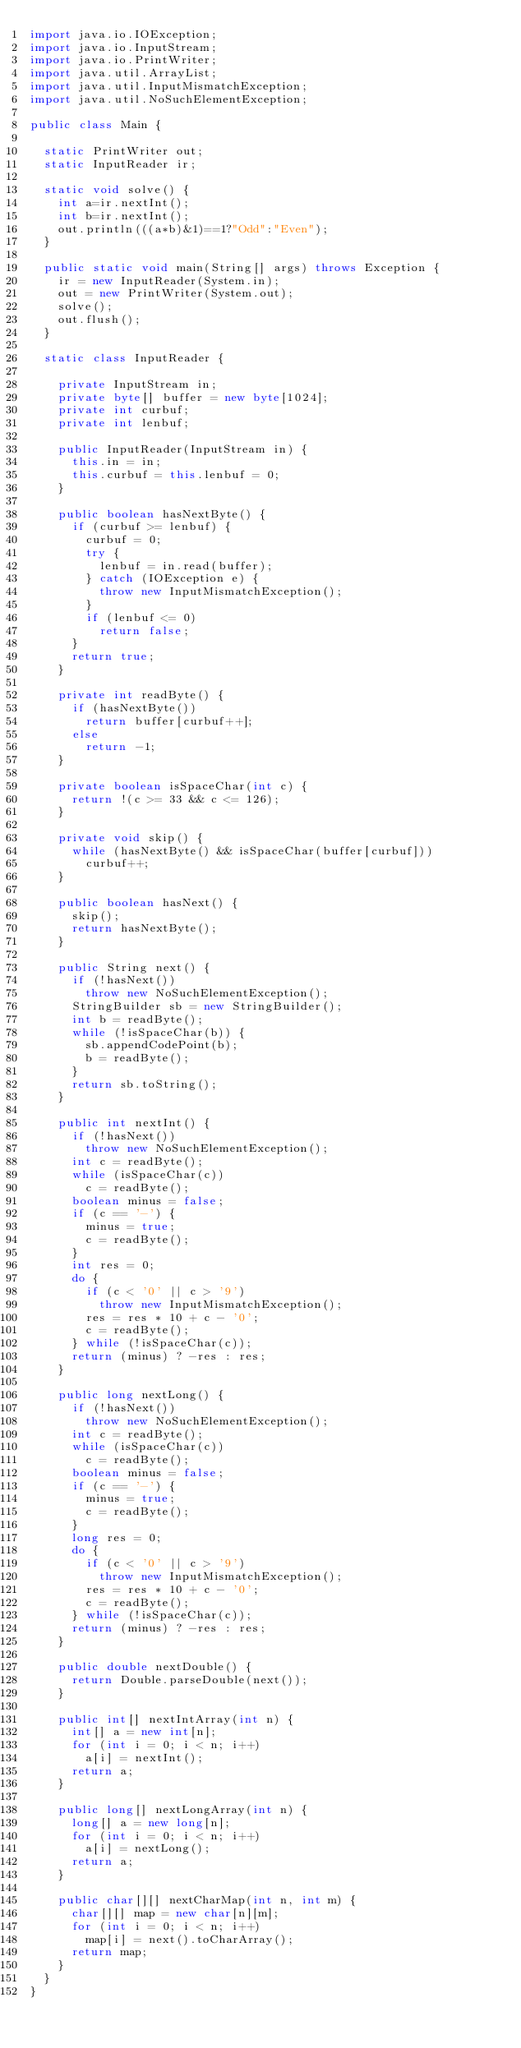<code> <loc_0><loc_0><loc_500><loc_500><_Java_>import java.io.IOException;
import java.io.InputStream;
import java.io.PrintWriter;
import java.util.ArrayList;
import java.util.InputMismatchException;
import java.util.NoSuchElementException;

public class Main {

	static PrintWriter out;
	static InputReader ir;

	static void solve() {
		int a=ir.nextInt();
		int b=ir.nextInt();
		out.println(((a*b)&1)==1?"Odd":"Even");
	}

	public static void main(String[] args) throws Exception {
		ir = new InputReader(System.in);
		out = new PrintWriter(System.out);
		solve();
		out.flush();
	}

	static class InputReader {

		private InputStream in;
		private byte[] buffer = new byte[1024];
		private int curbuf;
		private int lenbuf;

		public InputReader(InputStream in) {
			this.in = in;
			this.curbuf = this.lenbuf = 0;
		}

		public boolean hasNextByte() {
			if (curbuf >= lenbuf) {
				curbuf = 0;
				try {
					lenbuf = in.read(buffer);
				} catch (IOException e) {
					throw new InputMismatchException();
				}
				if (lenbuf <= 0)
					return false;
			}
			return true;
		}

		private int readByte() {
			if (hasNextByte())
				return buffer[curbuf++];
			else
				return -1;
		}

		private boolean isSpaceChar(int c) {
			return !(c >= 33 && c <= 126);
		}

		private void skip() {
			while (hasNextByte() && isSpaceChar(buffer[curbuf]))
				curbuf++;
		}

		public boolean hasNext() {
			skip();
			return hasNextByte();
		}

		public String next() {
			if (!hasNext())
				throw new NoSuchElementException();
			StringBuilder sb = new StringBuilder();
			int b = readByte();
			while (!isSpaceChar(b)) {
				sb.appendCodePoint(b);
				b = readByte();
			}
			return sb.toString();
		}

		public int nextInt() {
			if (!hasNext())
				throw new NoSuchElementException();
			int c = readByte();
			while (isSpaceChar(c))
				c = readByte();
			boolean minus = false;
			if (c == '-') {
				minus = true;
				c = readByte();
			}
			int res = 0;
			do {
				if (c < '0' || c > '9')
					throw new InputMismatchException();
				res = res * 10 + c - '0';
				c = readByte();
			} while (!isSpaceChar(c));
			return (minus) ? -res : res;
		}

		public long nextLong() {
			if (!hasNext())
				throw new NoSuchElementException();
			int c = readByte();
			while (isSpaceChar(c))
				c = readByte();
			boolean minus = false;
			if (c == '-') {
				minus = true;
				c = readByte();
			}
			long res = 0;
			do {
				if (c < '0' || c > '9')
					throw new InputMismatchException();
				res = res * 10 + c - '0';
				c = readByte();
			} while (!isSpaceChar(c));
			return (minus) ? -res : res;
		}

		public double nextDouble() {
			return Double.parseDouble(next());
		}

		public int[] nextIntArray(int n) {
			int[] a = new int[n];
			for (int i = 0; i < n; i++)
				a[i] = nextInt();
			return a;
		}

		public long[] nextLongArray(int n) {
			long[] a = new long[n];
			for (int i = 0; i < n; i++)
				a[i] = nextLong();
			return a;
		}

		public char[][] nextCharMap(int n, int m) {
			char[][] map = new char[n][m];
			for (int i = 0; i < n; i++)
				map[i] = next().toCharArray();
			return map;
		}
	}
}</code> 